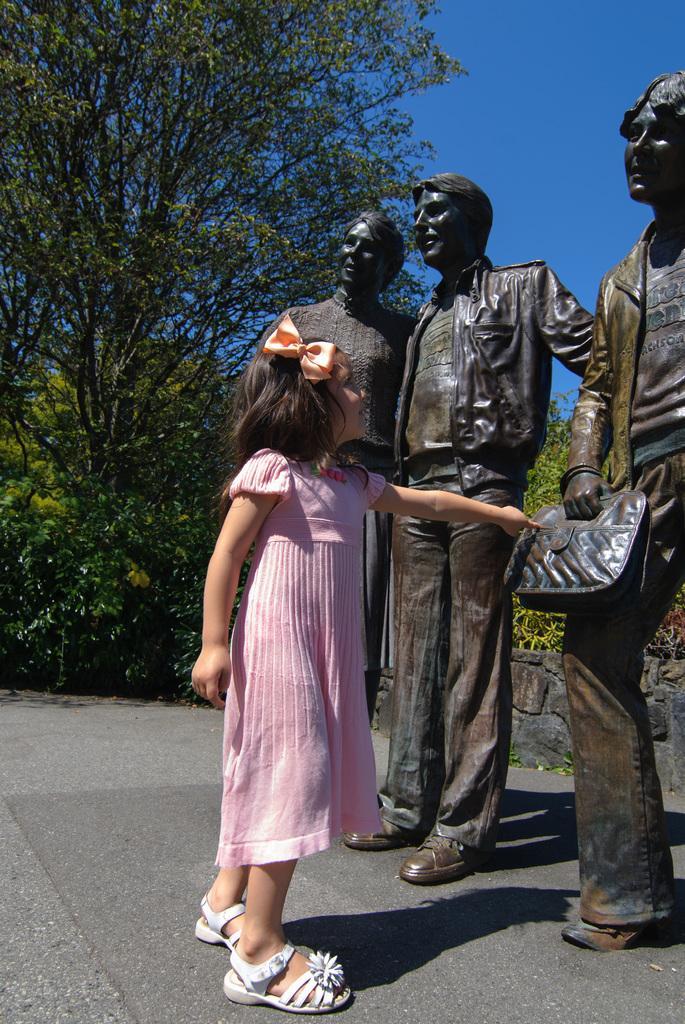How would you summarize this image in a sentence or two? In this image I can see the person standing and the person is wearing pink color dress and I can see three persons statues. In the background I can see few trees in green color and the sky is in blue color. 